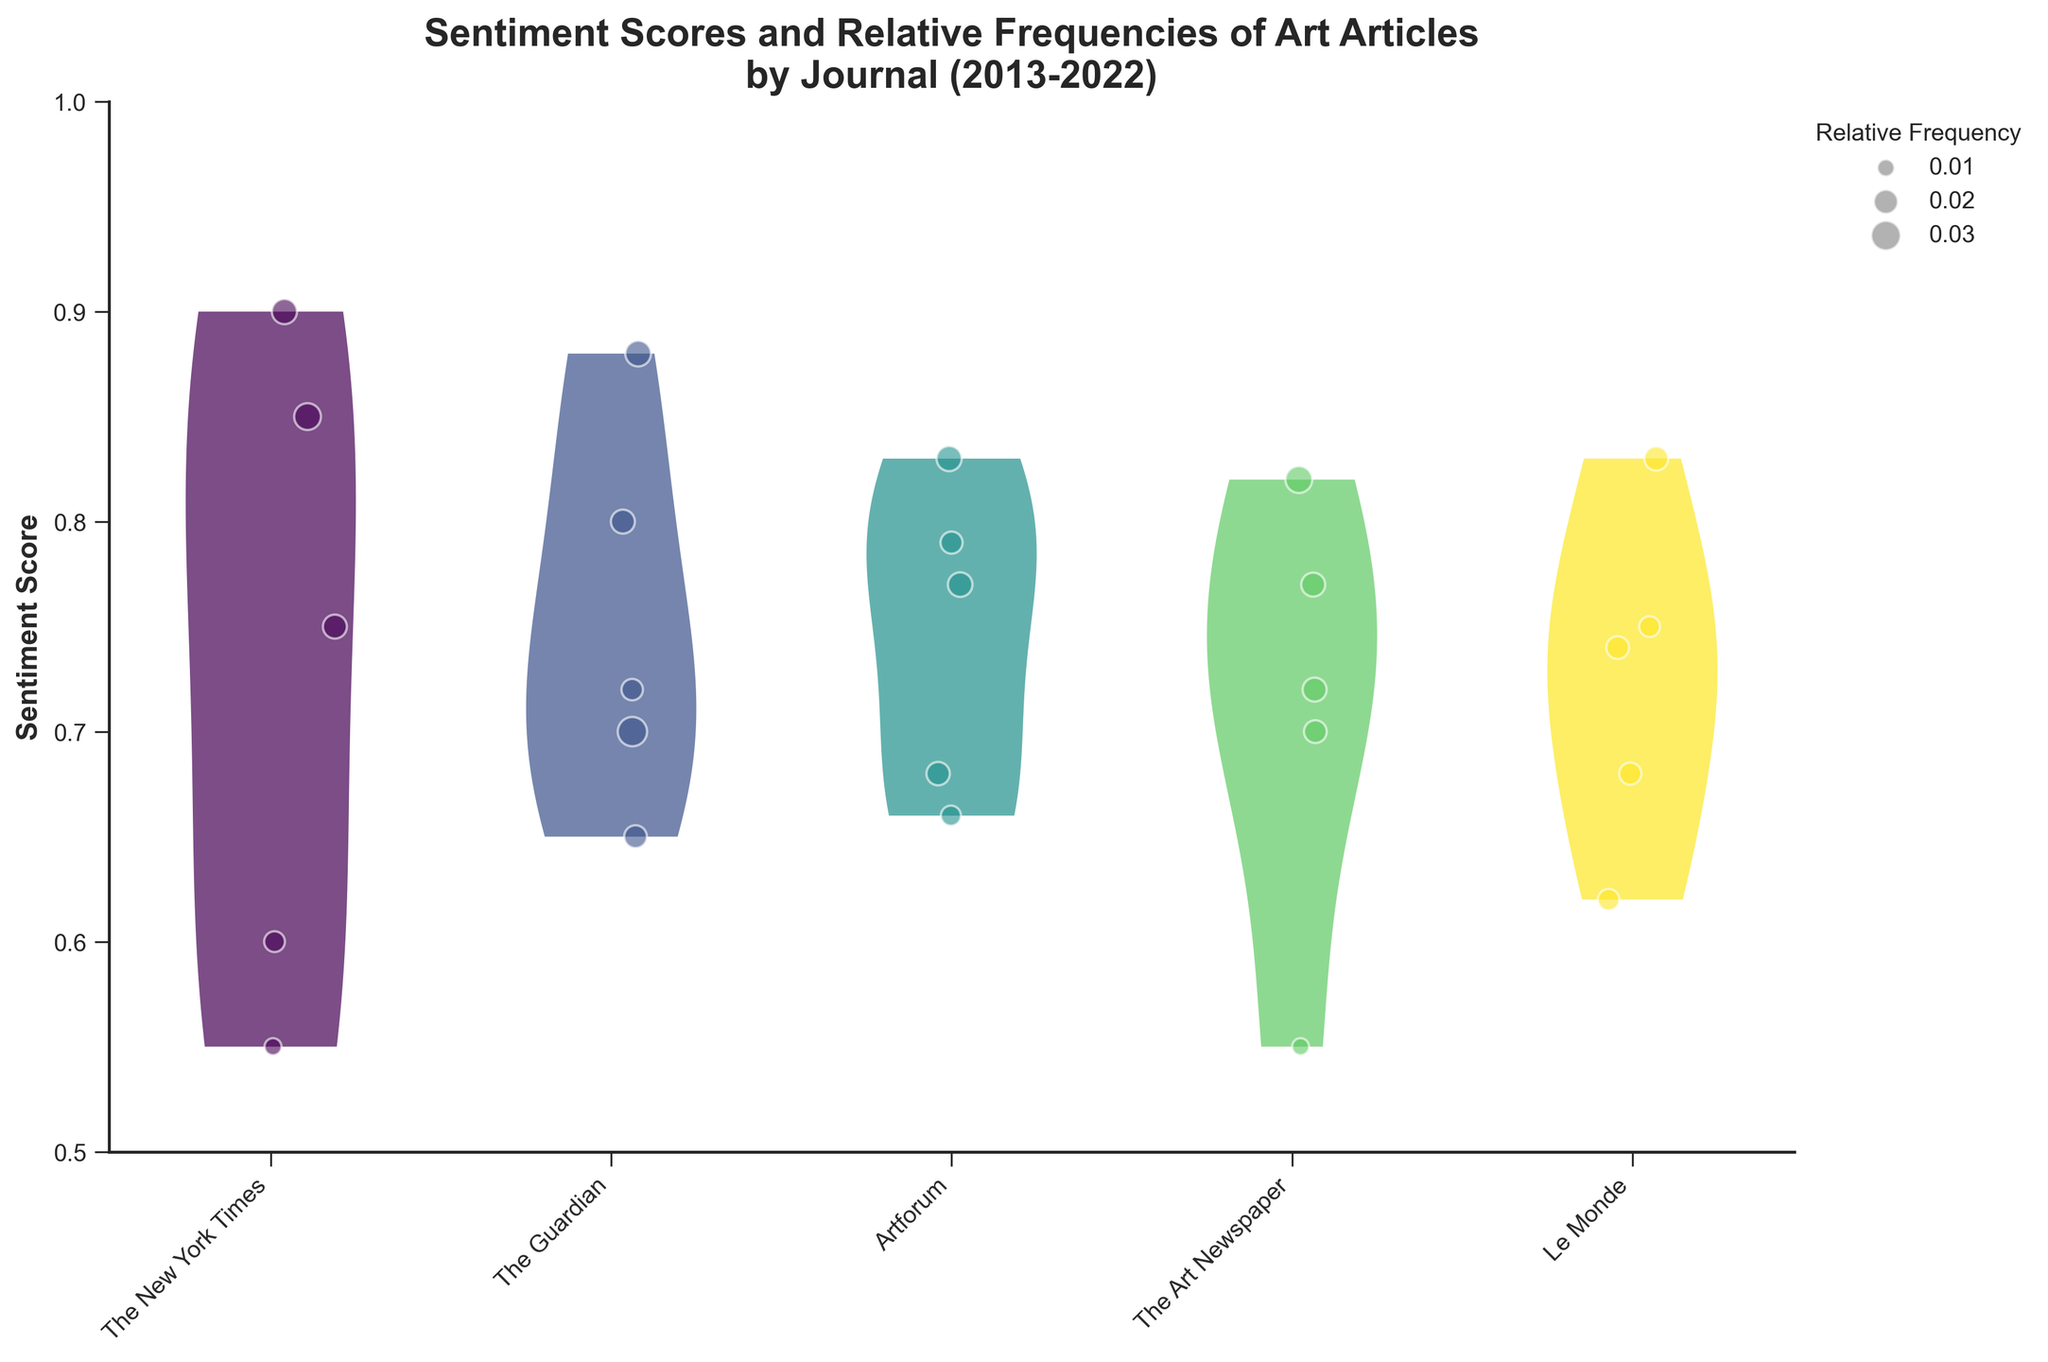How many journals are represented in the figure? The figure displays distinct colors for each journal, and by counting the different colors used, we can determine the number of journals. There are five different colors indicating five unique journals.
Answer: Five What is the title of the figure? The title of the figure is prominently displayed at the top of the plot. It reads "Sentiment Scores and Relative Frequencies of Art Articles by Journal (2013-2022)."
Answer: Sentiment Scores and Relative Frequencies of Art Articles by Journal (2013-2022) Which journal has the highest average sentiment score? To determine the journal with the highest average sentiment score, we observe the density and spread of the violin plots and the concentrations of jittered points. "The New York Times" shows a higher concentration towards the upper range compared to other journals.
Answer: The New York Times Which journal shows the largest relative frequency for any article? Observing the jittered scatter points, the size of the points indicates relative frequencies. The largest point corresponds to "The Guardian" in 2014. This point is significantly larger than others, indicating the highest relative frequency of 0.03.
Answer: The Guardian Which journal has the widest range of sentiment scores? By examining the extent of the violin plots along the y-axis, the journal with the largest range is "The New York Times." It displays the most spread in sentiment scores from about 0.55 to 0.90, implying a wider distribution.
Answer: The New York Times Compare the sentiment scores of "The Guardian" and "Artforum." Which one has generally higher sentiment scores? By comparing the central tendencies and distributions of the violin plots of both journals, "The Guardian" appears to have sentiment scores generally higher, as its plot shows denser scores in the upper range between 0.65 to 0.88.
Answer: The Guardian Which article published in "The Art Newspaper" has the lowest sentiment score? By identifying the smallest jittered point for "The Art Newspaper," in combination with its lateness in the timeline, the article "Pandemic's Impact on the Art World" in 2020, with a sentiment score of 0.55, is the lowest.
Answer: Pandemic's Impact on the Art World What is the average sentiment score for the articles published in "Le Monde"? To find the average sentiment score for "Le Monde," we look at the scatter points and consider their spread within the violin plot. The sentiments range from about 0.62 to 0.83. Taking an average of these points: (0.74+0.62+0.68+0.75+0.83)/5 ≈ 0.724.
Answer: 0.724 Do "The New York Times" and "The Art Newspaper” have any articles with a relative frequency of 0.01? By closely examining the sizes of the scatter points, "The New York Times" has one article ("Street Art: Voices from the Margins") with a relative frequency of 0.01, as well as "The Art Newspaper" with one article ("Pandemic's Impact on the Art World").
Answer: Yes 